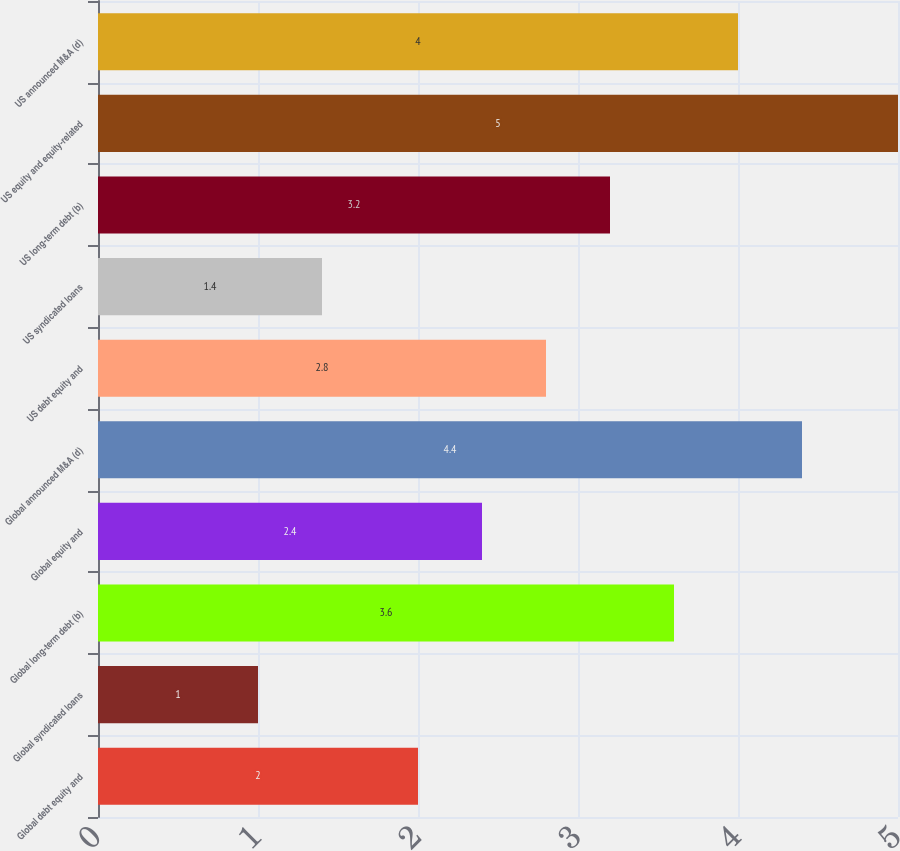<chart> <loc_0><loc_0><loc_500><loc_500><bar_chart><fcel>Global debt equity and<fcel>Global syndicated loans<fcel>Global long-term debt (b)<fcel>Global equity and<fcel>Global announced M&A (d)<fcel>US debt equity and<fcel>US syndicated loans<fcel>US long-term debt (b)<fcel>US equity and equity-related<fcel>US announced M&A (d)<nl><fcel>2<fcel>1<fcel>3.6<fcel>2.4<fcel>4.4<fcel>2.8<fcel>1.4<fcel>3.2<fcel>5<fcel>4<nl></chart> 